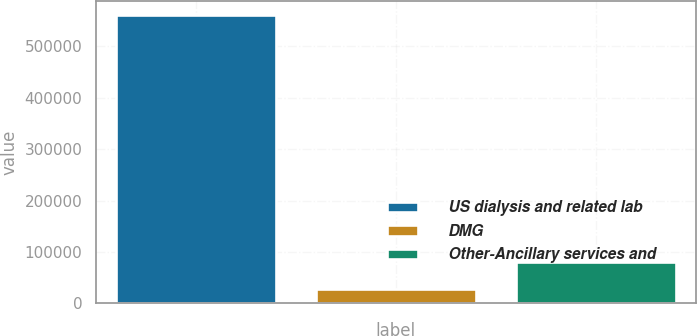Convert chart to OTSL. <chart><loc_0><loc_0><loc_500><loc_500><bar_chart><fcel>US dialysis and related lab<fcel>DMG<fcel>Other-Ancillary services and<nl><fcel>560610<fcel>27885<fcel>81157.5<nl></chart> 